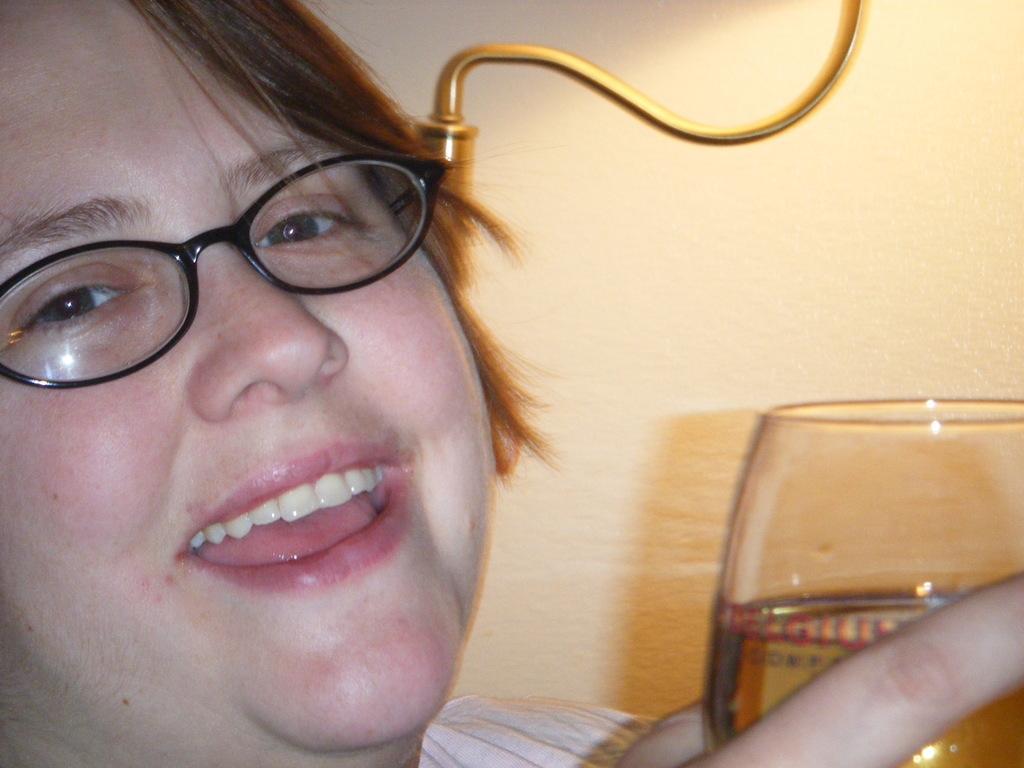Please provide a concise description of this image. There is a lady wearing specs is smiling and holding a glass. In the back there is a wall. 